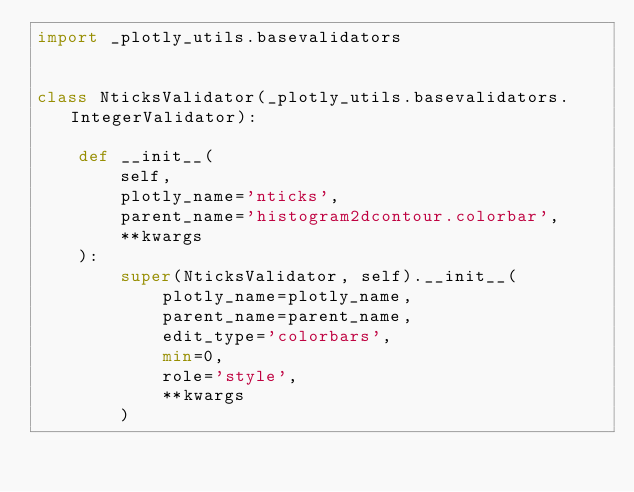Convert code to text. <code><loc_0><loc_0><loc_500><loc_500><_Python_>import _plotly_utils.basevalidators


class NticksValidator(_plotly_utils.basevalidators.IntegerValidator):

    def __init__(
        self,
        plotly_name='nticks',
        parent_name='histogram2dcontour.colorbar',
        **kwargs
    ):
        super(NticksValidator, self).__init__(
            plotly_name=plotly_name,
            parent_name=parent_name,
            edit_type='colorbars',
            min=0,
            role='style',
            **kwargs
        )
</code> 